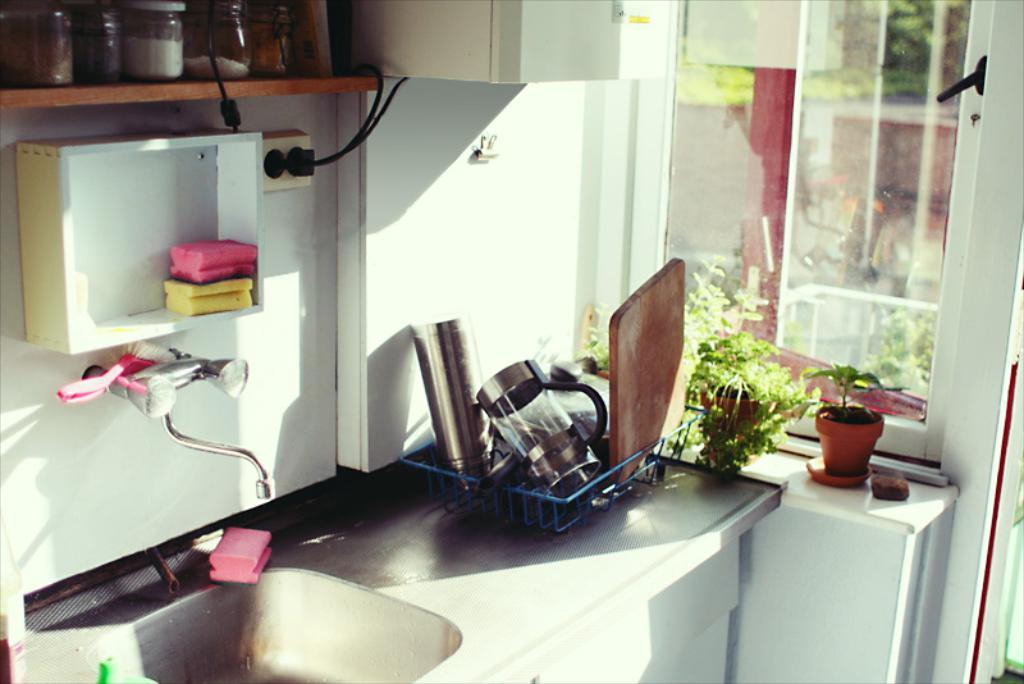What type of room is shown in the image? The image shows the inner view of a kitchen. What is one specific feature of the kitchen that can be seen? There is a sink in the kitchen. What is connected to the sink in the kitchen? There is a tap in the kitchen. What type of storage containers are present in the kitchen? There are pet jars in the kitchen. What type of wiring is present in the kitchen? Electric cables are present in the kitchen. Where are the utensils stored in the kitchen? The utensils are in a stand in the kitchen. What type of greenery is present in the kitchen? House plants are in the kitchen. What type of cleaning supplies are present in the kitchen? Detergent soaps are in the kitchen. What type of yam is being prepared on the counter in the kitchen? There is no yam present in the image; it only shows house plants and detergent soaps. How many boys are visible in the kitchen? There are no boys visible in the kitchen; the image only shows objects and not people. 